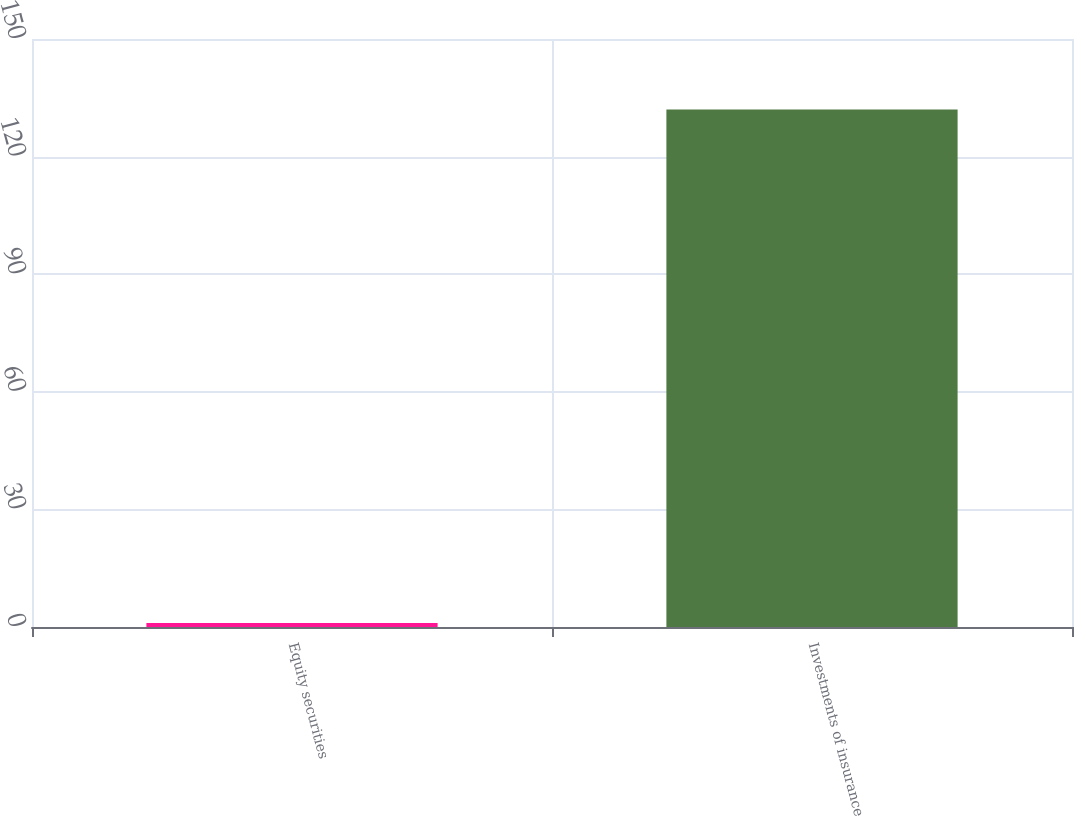Convert chart to OTSL. <chart><loc_0><loc_0><loc_500><loc_500><bar_chart><fcel>Equity securities<fcel>Investments of insurance<nl><fcel>1<fcel>132<nl></chart> 